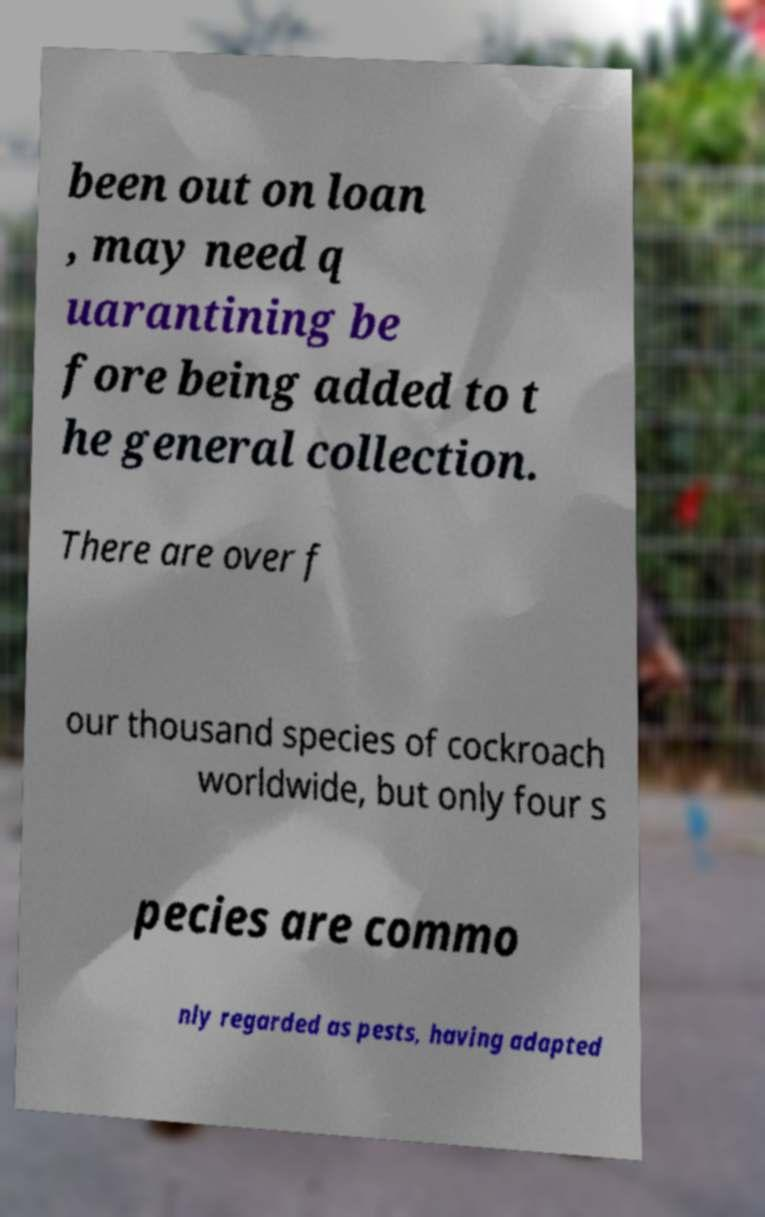For documentation purposes, I need the text within this image transcribed. Could you provide that? been out on loan , may need q uarantining be fore being added to t he general collection. There are over f our thousand species of cockroach worldwide, but only four s pecies are commo nly regarded as pests, having adapted 